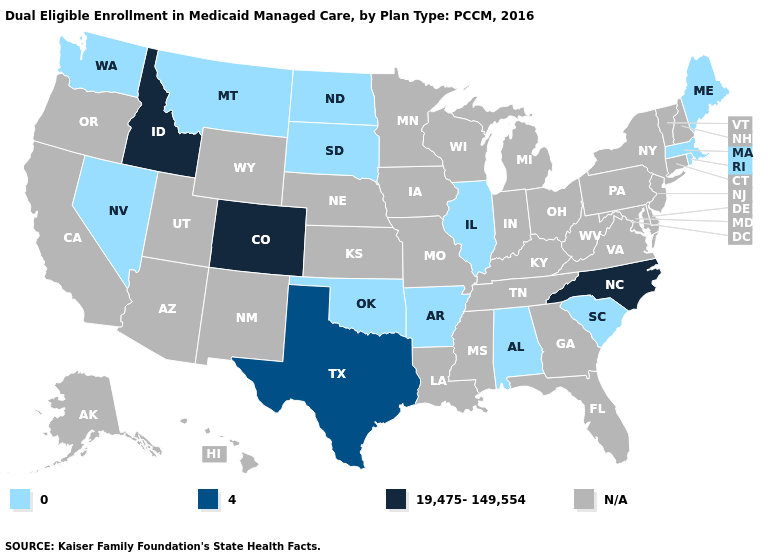Does Arkansas have the lowest value in the South?
Keep it brief. Yes. What is the value of Louisiana?
Keep it brief. N/A. Name the states that have a value in the range N/A?
Give a very brief answer. Alaska, Arizona, California, Connecticut, Delaware, Florida, Georgia, Hawaii, Indiana, Iowa, Kansas, Kentucky, Louisiana, Maryland, Michigan, Minnesota, Mississippi, Missouri, Nebraska, New Hampshire, New Jersey, New Mexico, New York, Ohio, Oregon, Pennsylvania, Tennessee, Utah, Vermont, Virginia, West Virginia, Wisconsin, Wyoming. What is the lowest value in the USA?
Concise answer only. 0. Name the states that have a value in the range 19,475-149,554?
Give a very brief answer. Colorado, Idaho, North Carolina. What is the value of Iowa?
Give a very brief answer. N/A. What is the highest value in the MidWest ?
Answer briefly. 0. How many symbols are there in the legend?
Give a very brief answer. 4. Which states have the highest value in the USA?
Keep it brief. Colorado, Idaho, North Carolina. Among the states that border Kentucky , which have the lowest value?
Keep it brief. Illinois. 